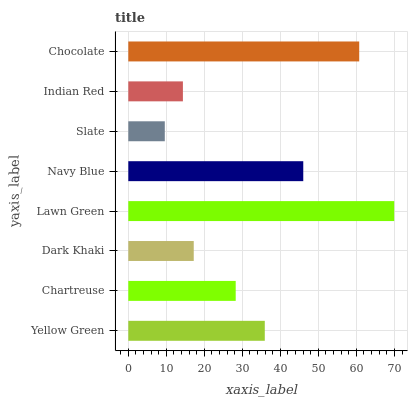Is Slate the minimum?
Answer yes or no. Yes. Is Lawn Green the maximum?
Answer yes or no. Yes. Is Chartreuse the minimum?
Answer yes or no. No. Is Chartreuse the maximum?
Answer yes or no. No. Is Yellow Green greater than Chartreuse?
Answer yes or no. Yes. Is Chartreuse less than Yellow Green?
Answer yes or no. Yes. Is Chartreuse greater than Yellow Green?
Answer yes or no. No. Is Yellow Green less than Chartreuse?
Answer yes or no. No. Is Yellow Green the high median?
Answer yes or no. Yes. Is Chartreuse the low median?
Answer yes or no. Yes. Is Slate the high median?
Answer yes or no. No. Is Indian Red the low median?
Answer yes or no. No. 